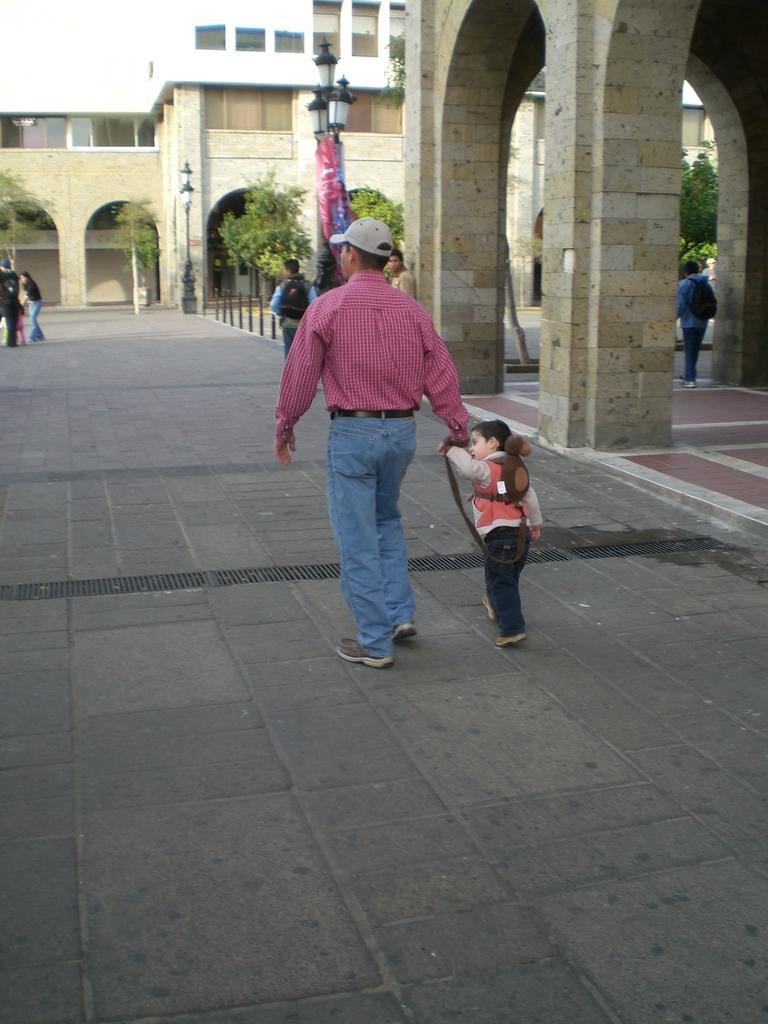What are the people in the image doing? Some people are standing, and some are walking in the image. What structures can be seen in the image? There are buildings in the image. What type of lighting is present in the image? There are pole lights in the image. What type of vegetation is present in the image? There are trees in the image. What is the condition of the sky in the image? The sky is cloudy in the image. Can you tell me how many friends the person in the image has? There is no specific person mentioned in the image, and therefore it is impossible to determine how many friends they might have. What type of push is being applied to the trees in the image? There is no indication of any force being applied to the trees in the image; they are simply standing in the background. 